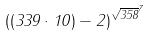Convert formula to latex. <formula><loc_0><loc_0><loc_500><loc_500>( ( 3 3 9 \cdot 1 0 ) - 2 ) ^ { \sqrt { 3 5 8 } ^ { 7 } }</formula> 